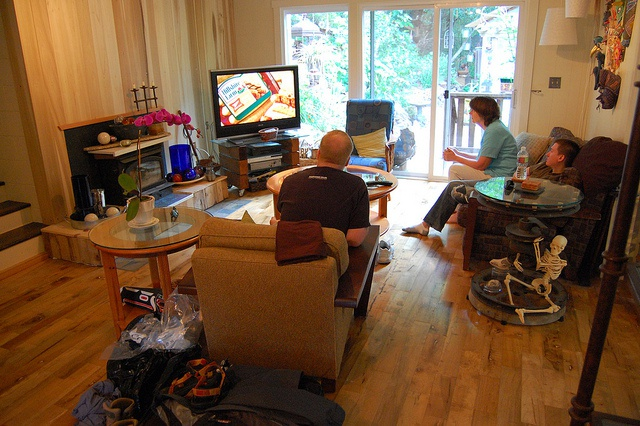Describe the objects in this image and their specific colors. I can see chair in maroon, black, and brown tones, couch in maroon, black, and gray tones, people in maroon, black, and brown tones, tv in maroon, ivory, black, khaki, and orange tones, and people in maroon, gray, black, and salmon tones in this image. 